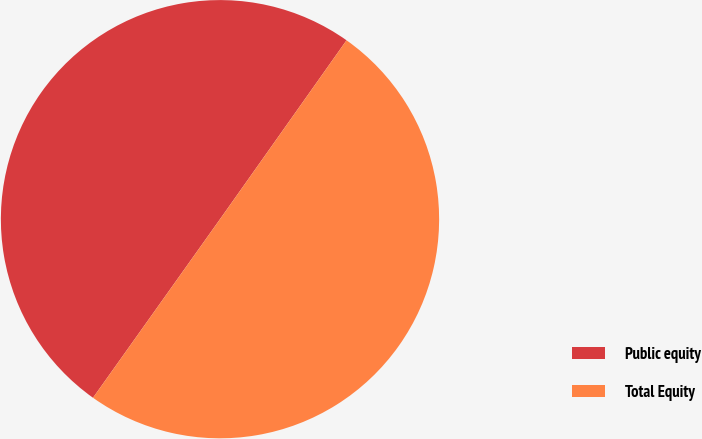Convert chart to OTSL. <chart><loc_0><loc_0><loc_500><loc_500><pie_chart><fcel>Public equity<fcel>Total Equity<nl><fcel>49.96%<fcel>50.04%<nl></chart> 